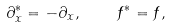Convert formula to latex. <formula><loc_0><loc_0><loc_500><loc_500>\partial _ { x } ^ { * } = - \partial _ { x } , \quad f ^ { * } = f ,</formula> 